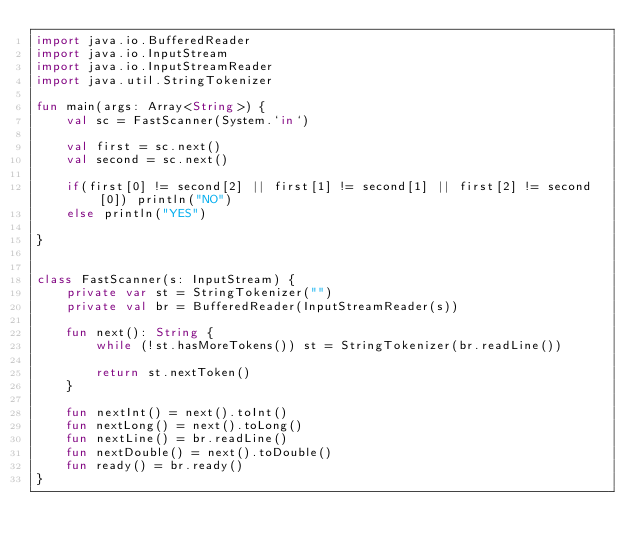<code> <loc_0><loc_0><loc_500><loc_500><_Kotlin_>import java.io.BufferedReader
import java.io.InputStream
import java.io.InputStreamReader
import java.util.StringTokenizer

fun main(args: Array<String>) {
    val sc = FastScanner(System.`in`)

    val first = sc.next()
    val second = sc.next()

    if(first[0] != second[2] || first[1] != second[1] || first[2] != second[0]) println("NO")
    else println("YES")

}


class FastScanner(s: InputStream) {
    private var st = StringTokenizer("")
    private val br = BufferedReader(InputStreamReader(s))

    fun next(): String {
        while (!st.hasMoreTokens()) st = StringTokenizer(br.readLine())

        return st.nextToken()
    }

    fun nextInt() = next().toInt()
    fun nextLong() = next().toLong()
    fun nextLine() = br.readLine()
    fun nextDouble() = next().toDouble()
    fun ready() = br.ready()
}


</code> 